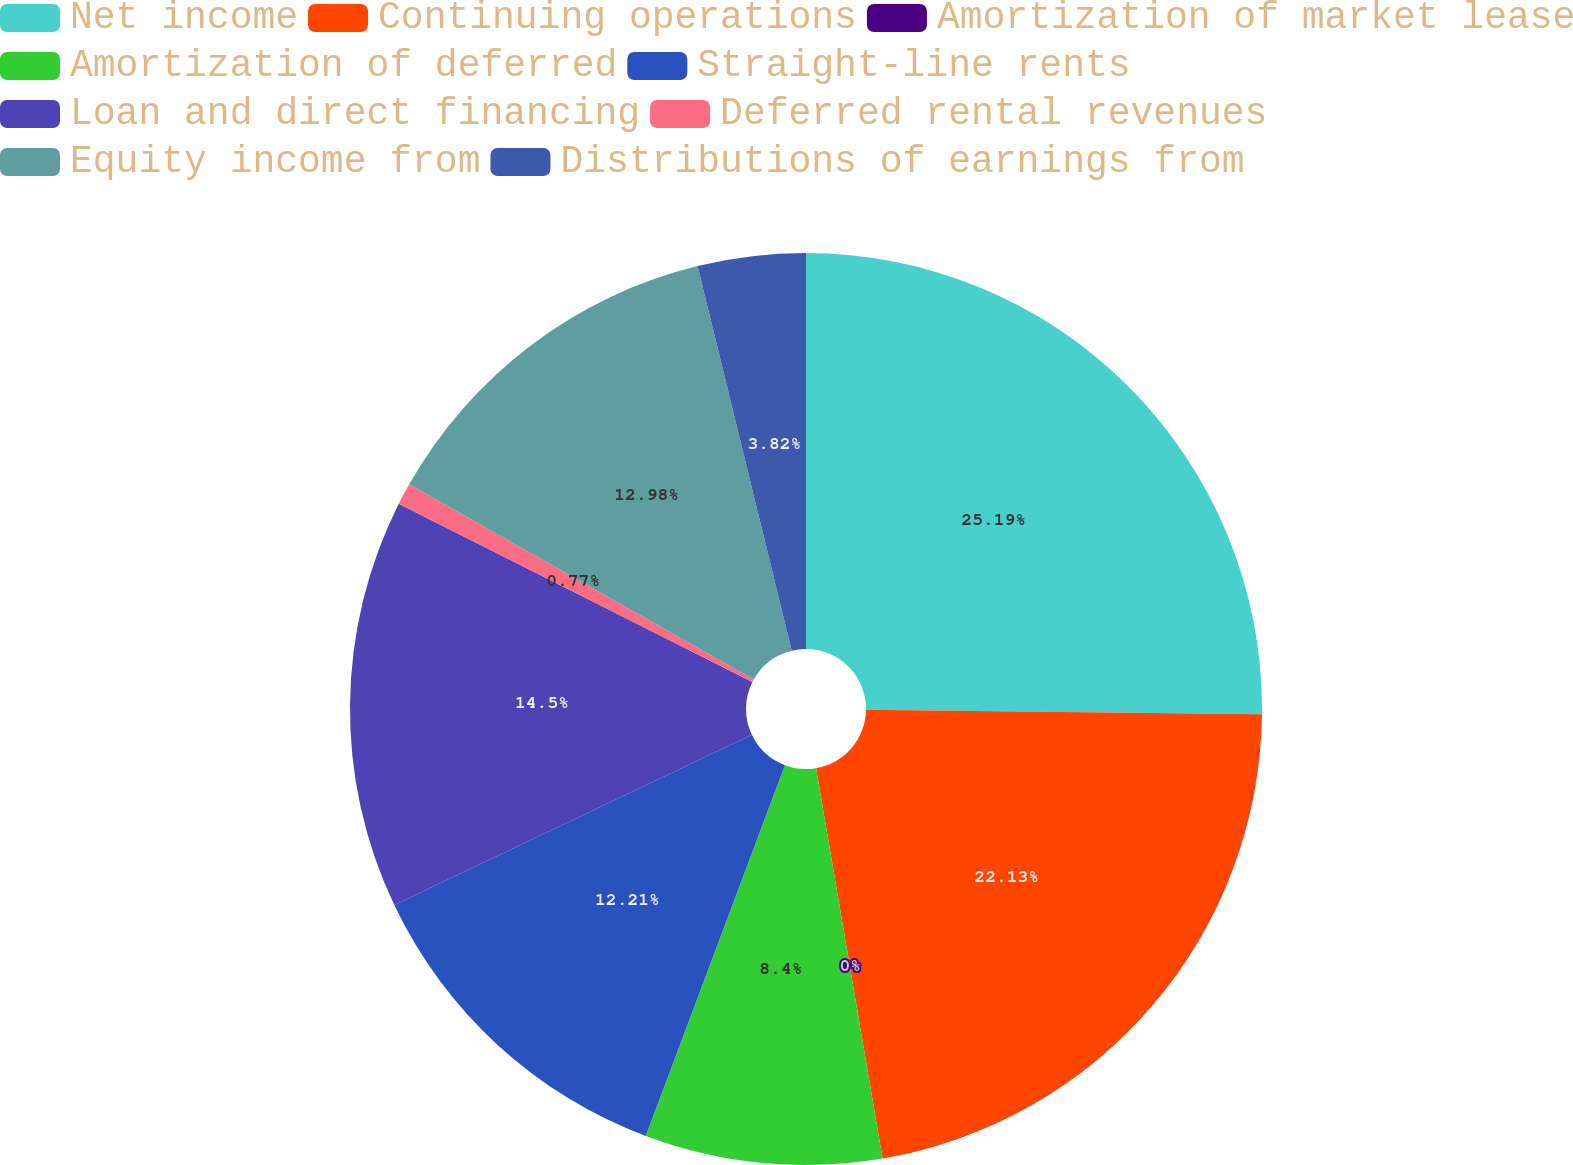Convert chart. <chart><loc_0><loc_0><loc_500><loc_500><pie_chart><fcel>Net income<fcel>Continuing operations<fcel>Amortization of market lease<fcel>Amortization of deferred<fcel>Straight-line rents<fcel>Loan and direct financing<fcel>Deferred rental revenues<fcel>Equity income from<fcel>Distributions of earnings from<nl><fcel>25.18%<fcel>22.13%<fcel>0.0%<fcel>8.4%<fcel>12.21%<fcel>14.5%<fcel>0.77%<fcel>12.98%<fcel>3.82%<nl></chart> 